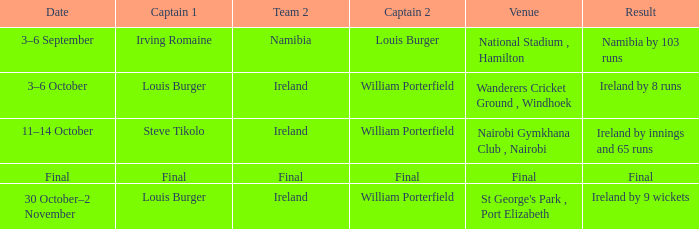In which instance does a captain 1 of louis burger have a date ranging from october 30th to november 2nd? Ireland by 9 wickets. 